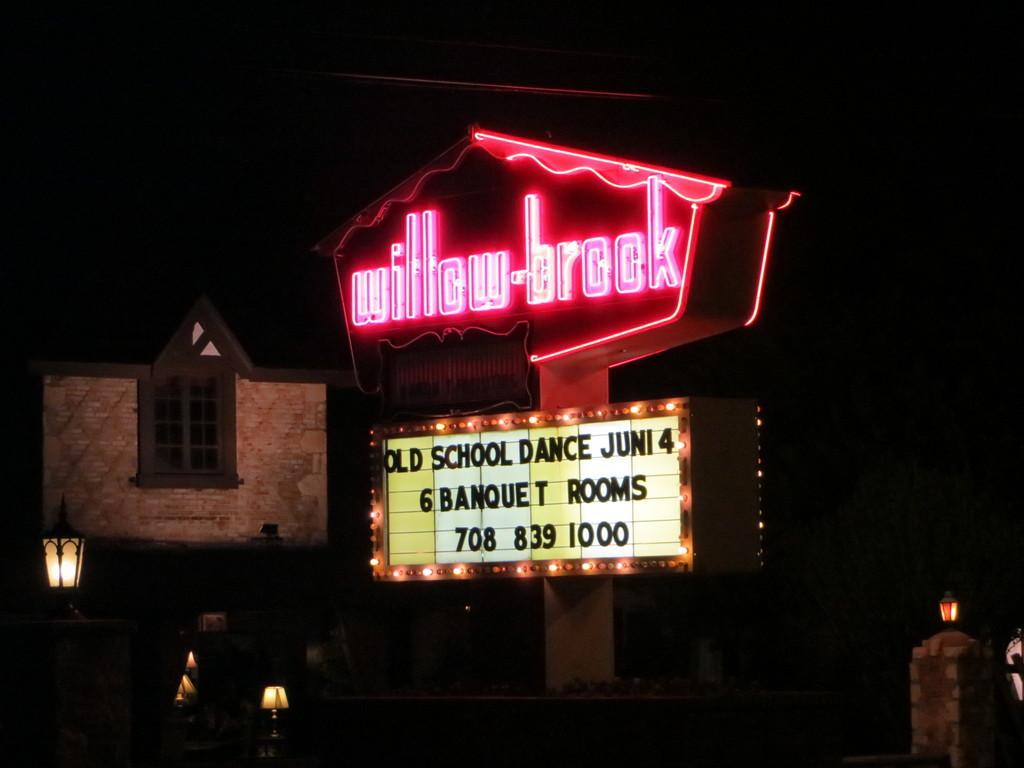Could you give a brief overview of what you see in this image? In this image there are light poles and there is a hoarding board for that board there are lights, in the background there is a house and it is dark. 